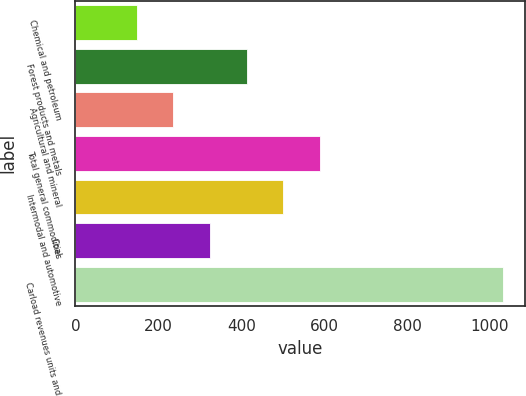Convert chart to OTSL. <chart><loc_0><loc_0><loc_500><loc_500><bar_chart><fcel>Chemical and petroleum<fcel>Forest products and metals<fcel>Agricultural and mineral<fcel>Total general commodities<fcel>Intermodal and automotive<fcel>Coal<fcel>Carload revenues units and<nl><fcel>147.9<fcel>413.16<fcel>236.32<fcel>590<fcel>501.58<fcel>324.74<fcel>1032.1<nl></chart> 